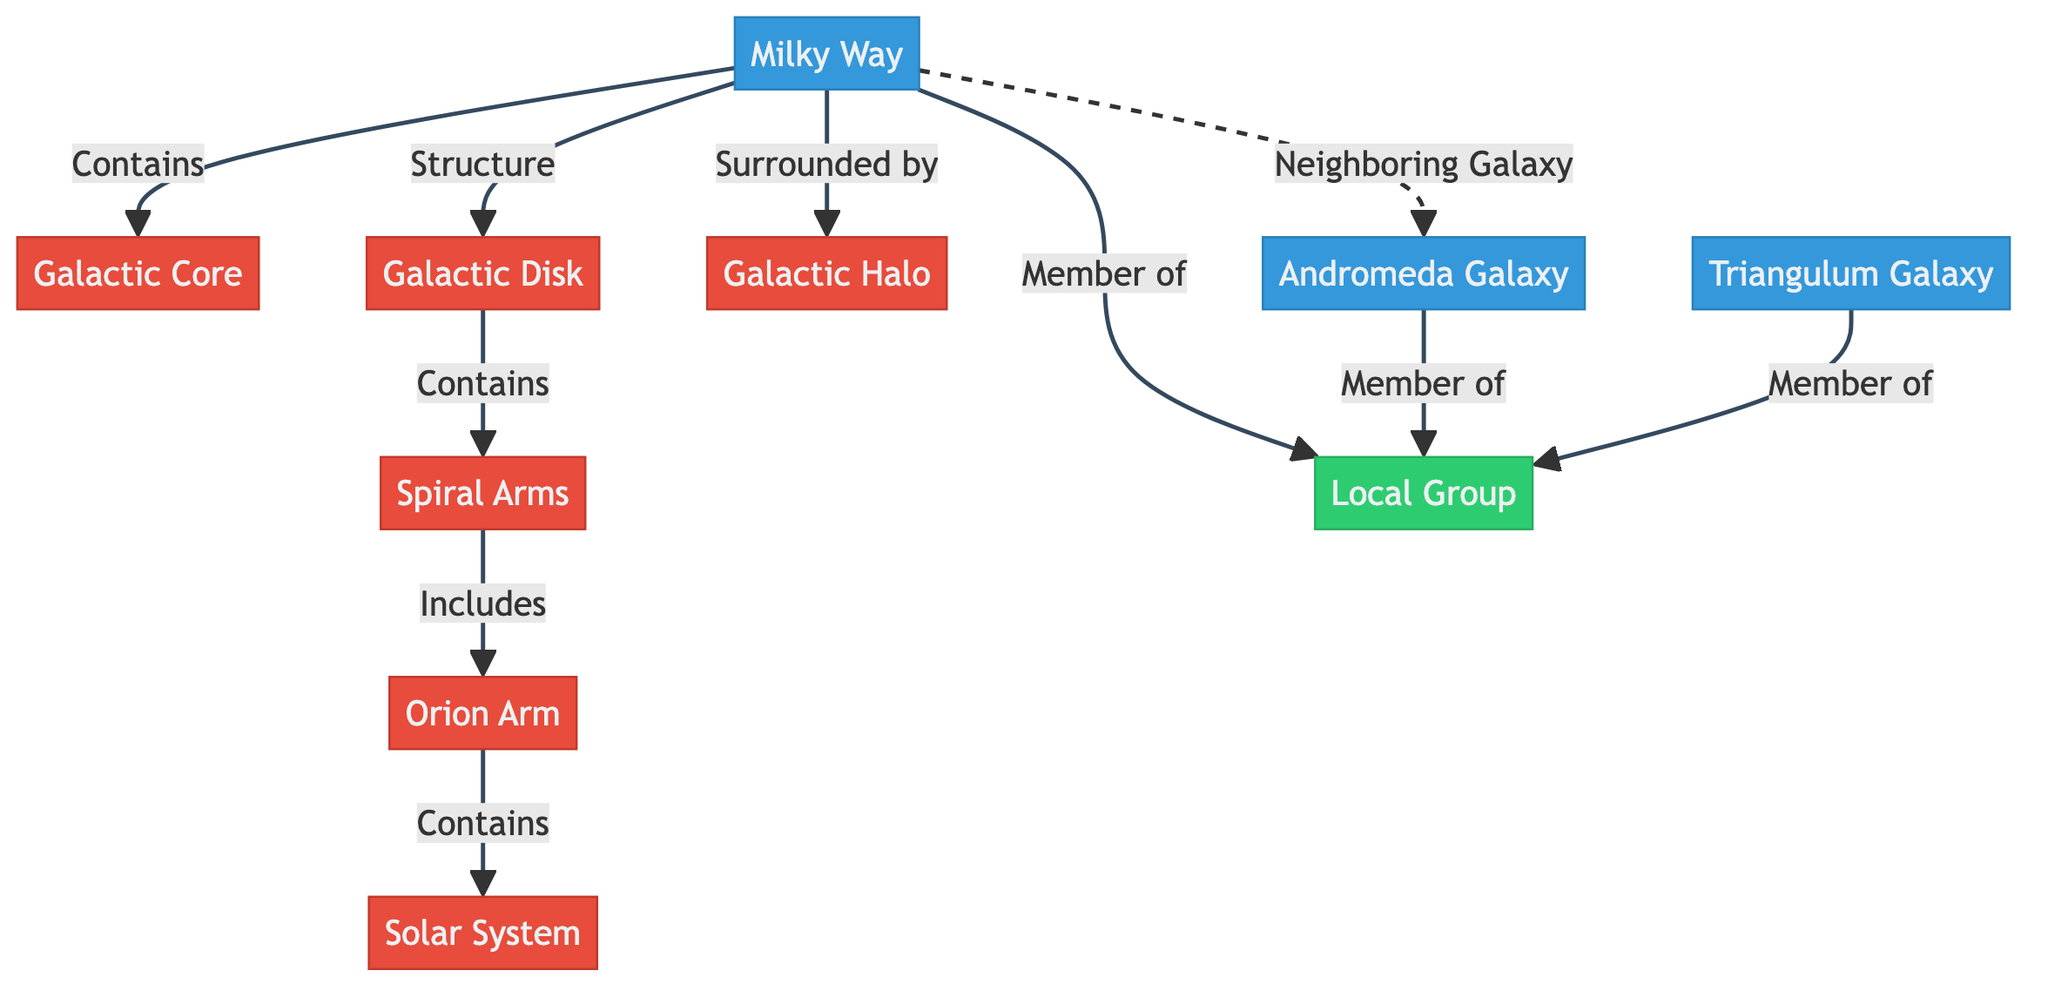What is the central feature of the Milky Way? The diagram lists the "Galactic Core" as a specific node connected directly to the "Milky Way," indicating it is the central feature.
Answer: Galactic Core How many spiral arms are there in the Milky Way? The diagram shows "Spiral Arms" as a single node connected to the "Galactic Disk," implying there can be multiple arms, but only mentions it in that singular fashion here. Therefore, only one main node is referenced, suggesting one category.
Answer: One What is the immediate neighboring galaxy to the Milky Way? The diagram clearly indicates "Andromeda Galaxy" as a neighboring galaxy through a dashed line, which means it is distinct from the directly connected components.
Answer: Andromeda Galaxy What does the Milky Way's structure include? The Milky Way comprises several components indicated in the diagram, including the "Galactic Core," "Galactic Disk," "Halo," and others, but specifically listed, so the answer will be one of its main structural components, which could be considered the "Galactic Disk."
Answer: Galactic Disk Which arm contains the Solar System? The diagram links "Solar System" under "Orion Arm," establishing a direct connection to locate the Solar System within the Orion Arm of the Milky Way.
Answer: Orion Arm How many galaxies are members of the Local Group stated in the diagram? The diagram indicates three galaxies: "Milky Way," "Andromeda Galaxy," and "Triangulum Galaxy," all shown as part of the "Local Group," so counting those gives three.
Answer: Three What surrounds the Milky Way? The diagram indicates "Halo" as a structural component that surrounds the main body of the Milky Way, providing the necessary information to respond to this question.
Answer: Halo Which structure in the Milky Way specifically includes the Solar System? The diagram shows that the "Solar System" specifically falls under the "Orion Arm," connecting the smaller component to its larger structure within the Milky Way.
Answer: Orion Arm What group does the Milky Way belong to? The diagram labels "Local Group" as the overarching group that the Milky Way is a member of, directly connecting the two elements.
Answer: Local Group 